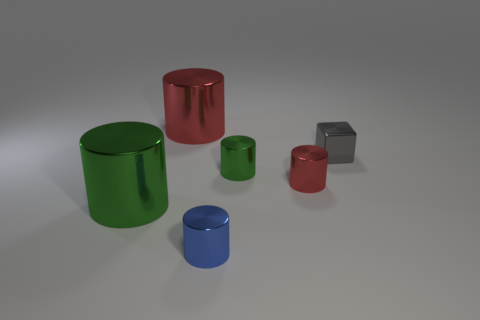Do the red cylinder left of the blue shiny cylinder and the red cylinder that is in front of the gray object have the same material?
Your answer should be compact. Yes. Are there any red cylinders?
Ensure brevity in your answer.  Yes. Are there more tiny gray cubes in front of the gray metallic block than red shiny objects that are left of the tiny blue object?
Ensure brevity in your answer.  No. There is a big metallic thing to the left of the large red cylinder; does it have the same color as the tiny cylinder that is behind the tiny red object?
Your response must be concise. Yes. What shape is the large green metallic object?
Offer a very short reply. Cylinder. Are there more cylinders in front of the small cube than big red metallic spheres?
Your response must be concise. Yes. The red metal thing behind the shiny block has what shape?
Ensure brevity in your answer.  Cylinder. What number of other things are there of the same shape as the small gray metallic thing?
Keep it short and to the point. 0. Do the green object left of the small blue shiny object and the small green cylinder have the same material?
Give a very brief answer. Yes. Are there an equal number of tiny blue metallic things that are behind the tiny metallic cube and large cylinders that are right of the big red object?
Your response must be concise. Yes. 